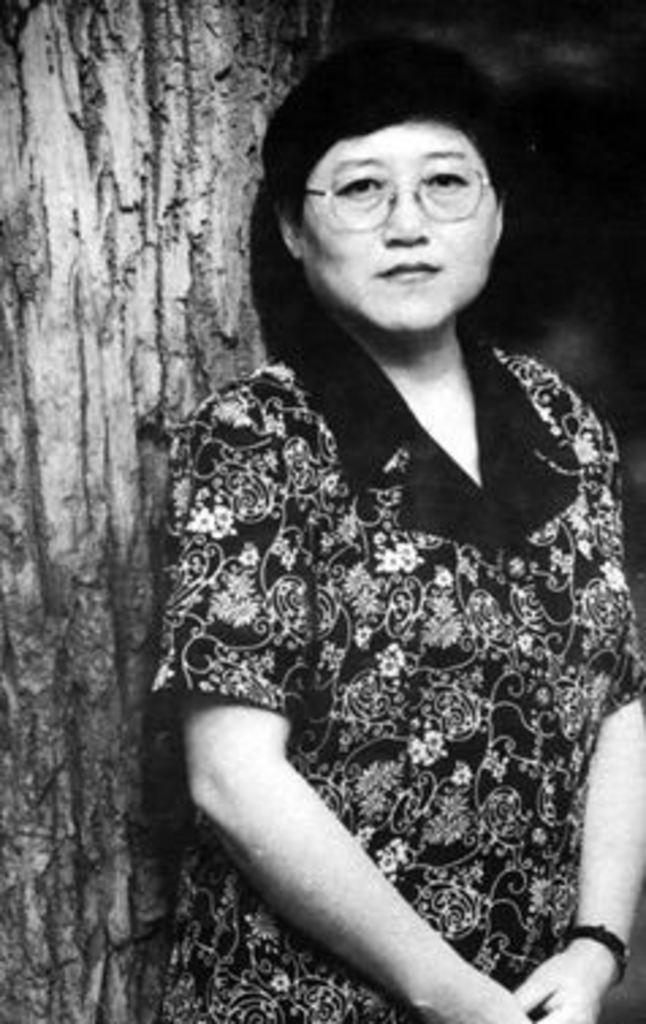What can be seen in the image? There is a person in the image. Can you describe the person's appearance? The person is wearing spectacles and a watch. What other object is present in the image? There is a wooden trunk in the image. What type of eggs can be seen in the image? There are no eggs present in the image. Is the pig wearing a hat in the image? There is no pig present in the image. 